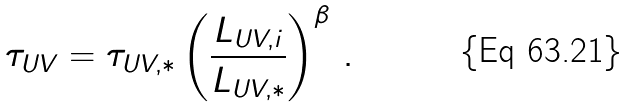Convert formula to latex. <formula><loc_0><loc_0><loc_500><loc_500>\tau _ { U V } = \tau _ { U V , * } \left ( \frac { L _ { U V , i } } { L _ { U V , * } } \right ) ^ { \beta } \, .</formula> 